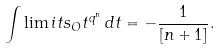Convert formula to latex. <formula><loc_0><loc_0><loc_500><loc_500>\int \lim i t s _ { O } t ^ { q ^ { n } } \, d t = - \frac { 1 } { [ n + 1 ] } .</formula> 